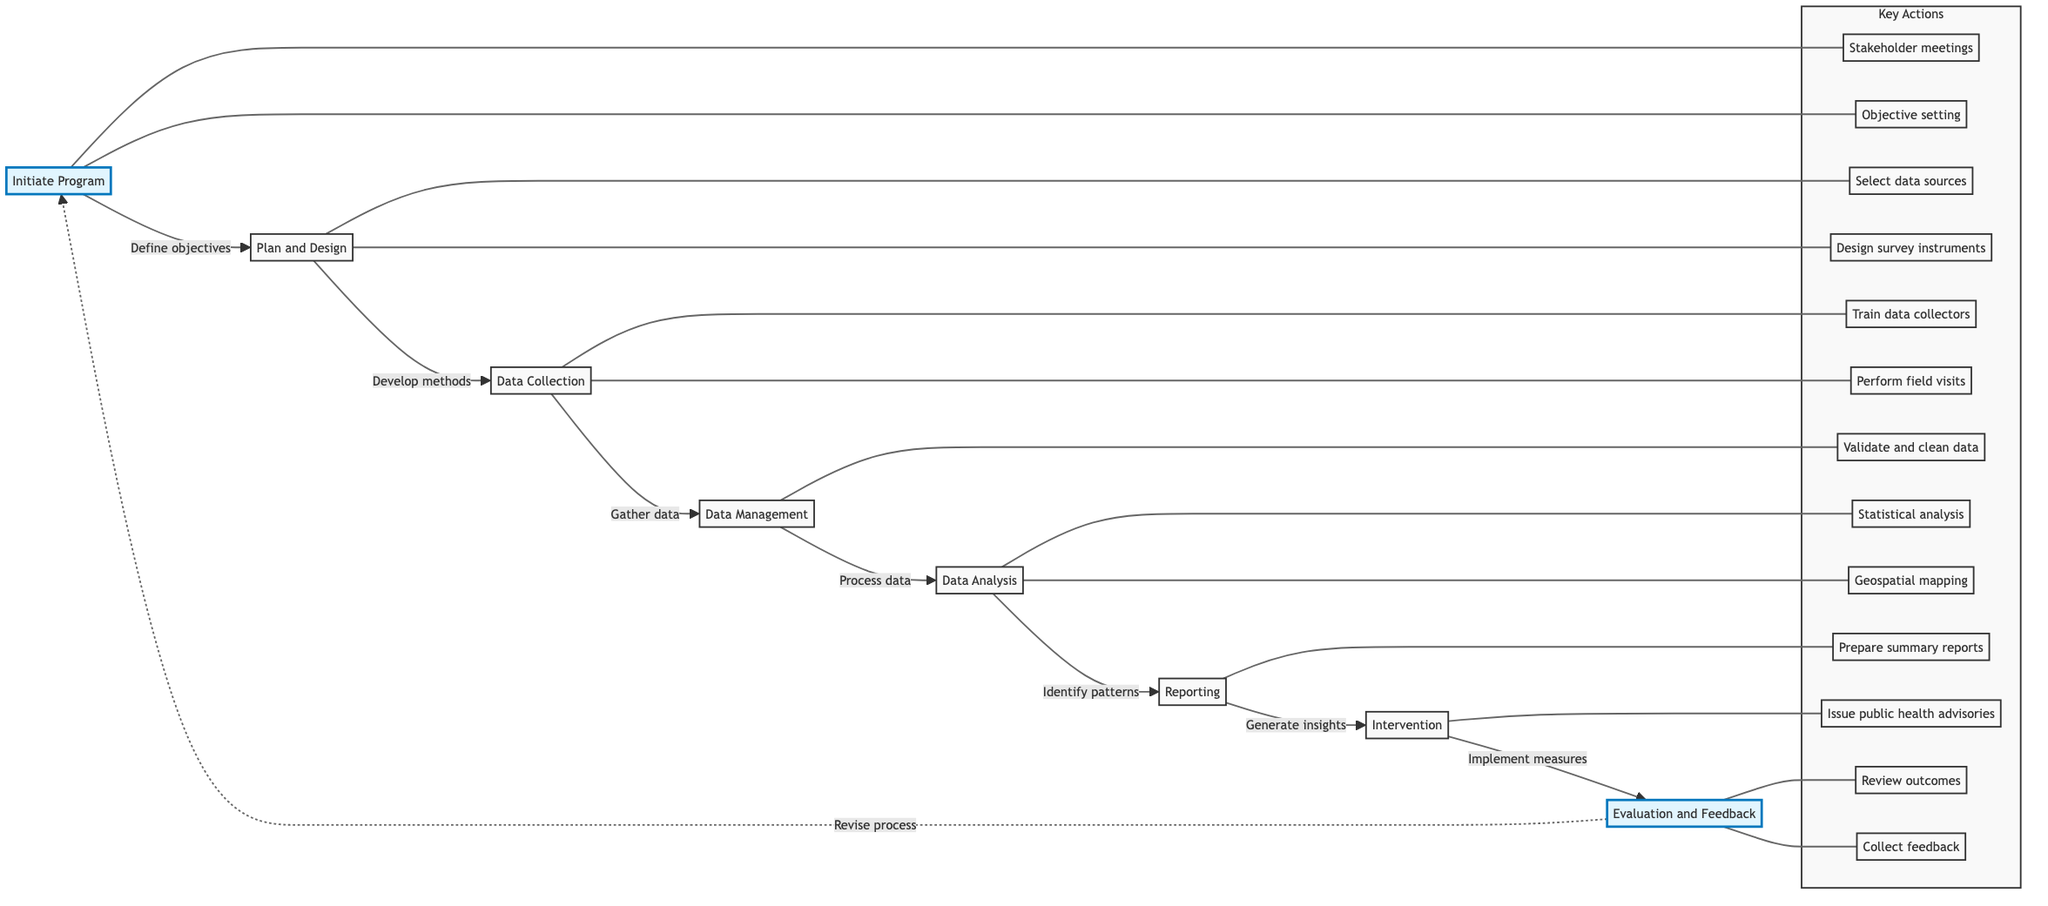What's the first step in the disease surveillance program? The diagram indicates that the first step is "Initiate Program," which is the starting point of the process.
Answer: Initiate Program How many key actions are associated with the "Data Management" step? By checking the diagram, "Data Management" has three key actions listed (Enter data into systems, Validate and clean data, Update databases).
Answer: 3 What is the relationship between "Data Analysis" and "Reporting"? The diagram shows an arrow leading from "Data Analysis" directly to "Reporting," indicating that reporting follows data analysis.
Answer: Data Analysis leads to Reporting Which step involves generating insights? Looking at the diagram, the step labeled "Data Analysis" mentions identifying patterns, which leads to the generation of insights in the "Reporting" step.
Answer: Data Analysis What defines the scope of the disease surveillance program? The diagram shows that defining objectives and scope occurs during the "Initiate Program" step.
Answer: Objectives and scope What are the two key actions in the "Plan and Design" step? The diagram indicates that the two key actions are selecting data sources and designing survey instruments, which are linked to the "Plan and Design" step.
Answer: Select data sources, Design survey instruments How does the process return to the "Initiate Program" step? The diagram illustrates that there is a dashed line leading from "Evaluation and Feedback" back to "Initiate Program," indicating a feedback loop for revisions.
Answer: Revise process What type of actions occur in the "Intervention" step? The diagram illustrates that interventions involve implementing control measures based on the findings of the surveillance program.
Answer: Implement control measures 